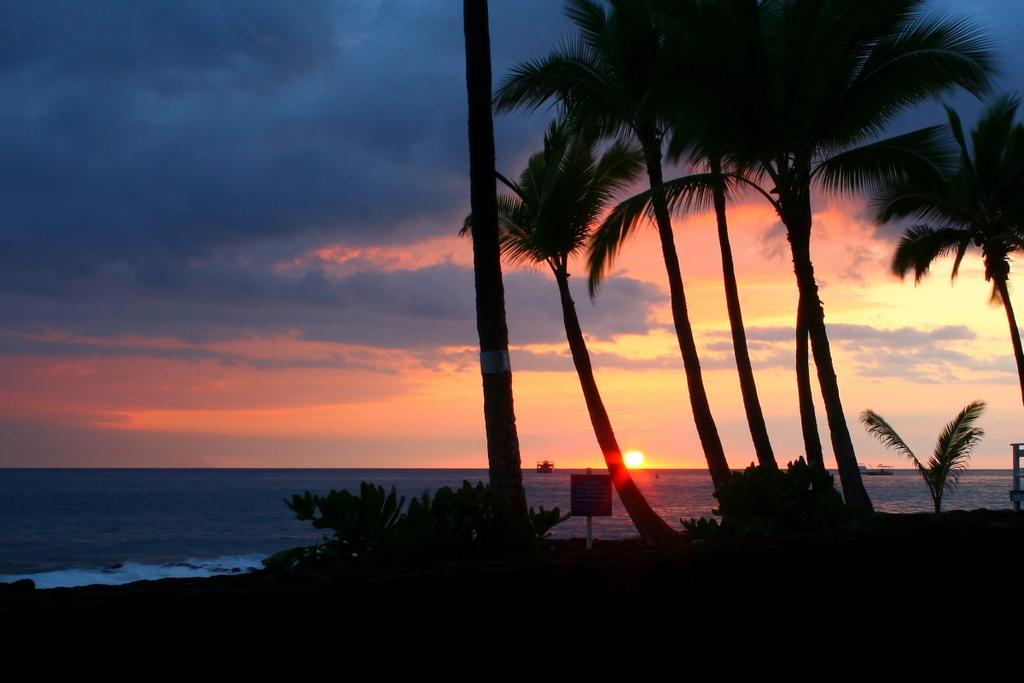Could you give a brief overview of what you see in this image? In this picture we can see water, trees, board and in the background we can see the sky with clouds. 